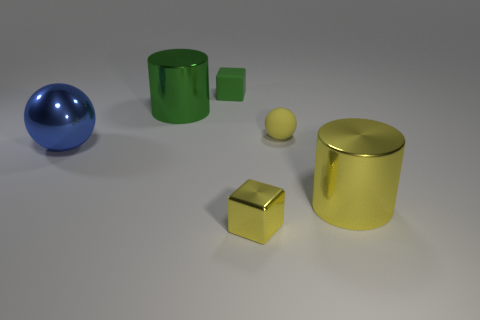Add 1 yellow cubes. How many objects exist? 7 Subtract all balls. How many objects are left? 4 Add 5 green cylinders. How many green cylinders are left? 6 Add 1 metal things. How many metal things exist? 5 Subtract 0 purple cubes. How many objects are left? 6 Subtract all blue things. Subtract all small green objects. How many objects are left? 4 